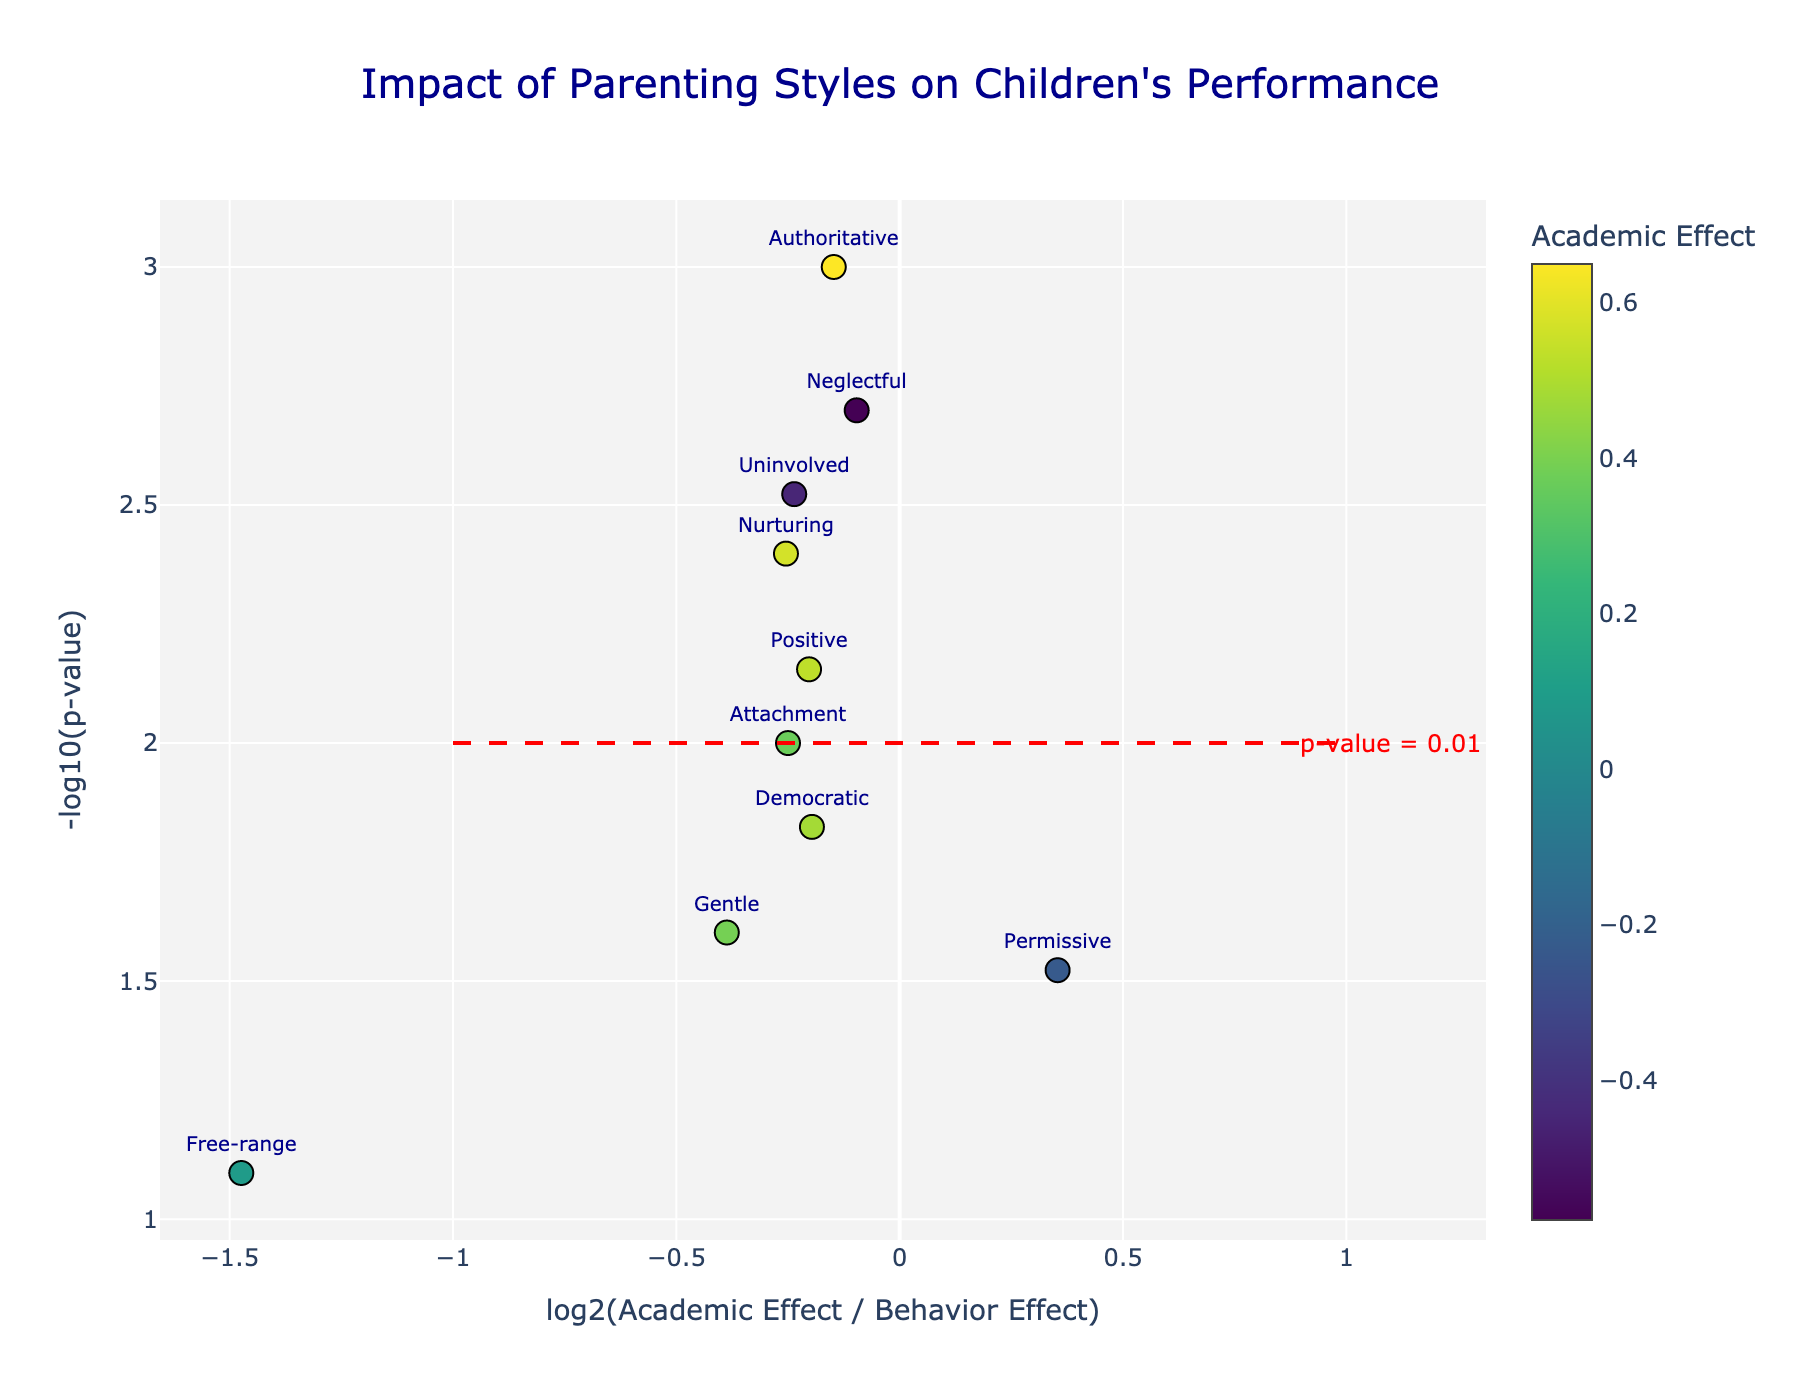What is the title of the figure? The title is typically located at the top of the figure and describes the main subject being visualized.
Answer: Impact of Parenting Styles on Children's Performance What do the colors of the markers represent? The color of the markers represents the 'Academic Effect' for each parenting style, which can be seen from the color bar on the right side of the plot.
Answer: Academic Effect Which parenting style has the highest academic effect? To find this, look for the marker with the most intense color on the color scale, as this corresponds to the highest academic effect.
Answer: Authoritative What do the x and y axes represent? The x-axis represents the log2 ratio of the Academic Effect to the Behavior Effect, while the y-axis represents the negative log10 of the p-value.
Answer: log2(Academic Effect / Behavior Effect) and -log10(p-value) How many data points exceed the significance threshold (p-value = 0.01) on the plot? Count the number of markers that lie above the horizontal red dashed line representing a p-value of 0.01.
Answer: 10 Which parenting style has the lowest behavior effect? Look for the parenting style with the lowest position along the y-axis (negative impact on behavior) among those markers with high negative changes in Academic Effect.
Answer: Neglectful Which parenting style shows a higher academic effect than behavior effect but with a p-value between 0.01 and 0.05? Identify the marker that lies to the right of the central line (positive x-axis) and between the −log10(p-value) values of 1.3 and 2.
Answer: Democratic Which data point has the smallest fold change? The smallest fold change can be found closest to the x=0 line, indicating the log2(Academic Effect / Behavior Effect) is smallest.
Answer: Free-range Which parenting style has the most balanced impact on both academic performance and behavior (close to the center)? The most balanced impact would be close to the center on the x-axis, meaning a log2 ratio near 0. This implies neither academic nor behavior effects are overwhelmingly higher or lower.
Answer: Authoritarian What is the y-value threshold for statistical significance in this plot? Refer to the horizontal red dashed line annotated with "p-value = 0.01" to determine the significance threshold.
Answer: 2 